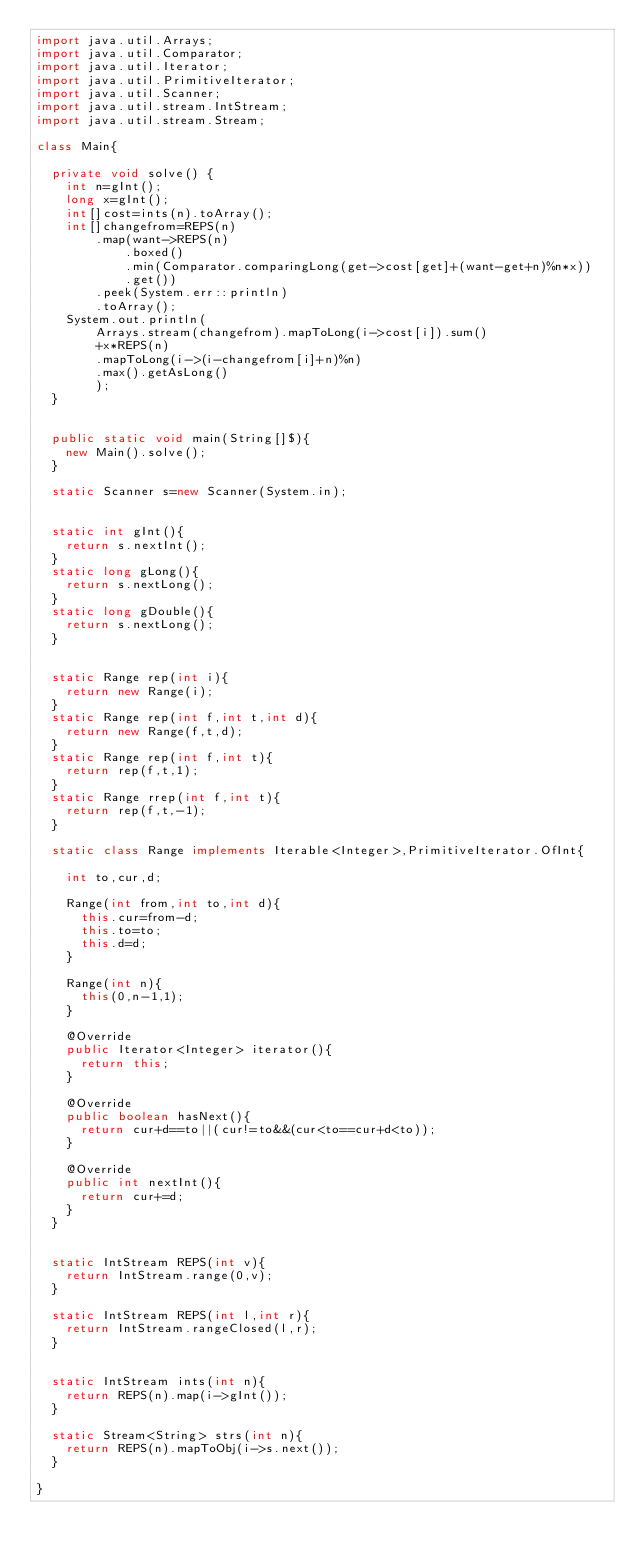<code> <loc_0><loc_0><loc_500><loc_500><_Java_>import java.util.Arrays;
import java.util.Comparator;
import java.util.Iterator;
import java.util.PrimitiveIterator;
import java.util.Scanner;
import java.util.stream.IntStream;
import java.util.stream.Stream;

class Main{

	private void solve() {
		int n=gInt();
		long x=gInt();
		int[]cost=ints(n).toArray();
		int[]changefrom=REPS(n)
				.map(want->REPS(n)
						.boxed()
						.min(Comparator.comparingLong(get->cost[get]+(want-get+n)%n*x))
						.get())
				.peek(System.err::println)
				.toArray();
		System.out.println(
				Arrays.stream(changefrom).mapToLong(i->cost[i]).sum()
				+x*REPS(n)
				.mapToLong(i->(i-changefrom[i]+n)%n)
				.max().getAsLong()
				);
	}


	public static void main(String[]$){
		new Main().solve();
	}

	static Scanner s=new Scanner(System.in);


	static int gInt(){
		return s.nextInt();
	}
	static long gLong(){
		return s.nextLong();
	}
	static long gDouble(){
		return s.nextLong();
	}


	static Range rep(int i){
		return new Range(i);
	}
	static Range rep(int f,int t,int d){
		return new Range(f,t,d);
	}
	static Range rep(int f,int t){
		return rep(f,t,1);
	}
	static Range rrep(int f,int t){
		return rep(f,t,-1);
	}

	static class Range implements Iterable<Integer>,PrimitiveIterator.OfInt{

		int to,cur,d;

		Range(int from,int to,int d){
			this.cur=from-d;
			this.to=to;
			this.d=d;
		}

		Range(int n){
			this(0,n-1,1);
		}

		@Override
		public Iterator<Integer> iterator(){
			return this;
		}

		@Override
		public boolean hasNext(){
			return cur+d==to||(cur!=to&&(cur<to==cur+d<to));
		}

		@Override
		public int nextInt(){
			return cur+=d;
		}
	}


	static IntStream REPS(int v){
		return IntStream.range(0,v);
	}

	static IntStream REPS(int l,int r){
		return IntStream.rangeClosed(l,r);
	}


	static IntStream ints(int n){
		return REPS(n).map(i->gInt());
	}

	static Stream<String> strs(int n){
		return REPS(n).mapToObj(i->s.next());
	}

}
</code> 